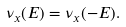Convert formula to latex. <formula><loc_0><loc_0><loc_500><loc_500>\nu _ { x } ( E ) = \nu _ { x } ( - E ) .</formula> 